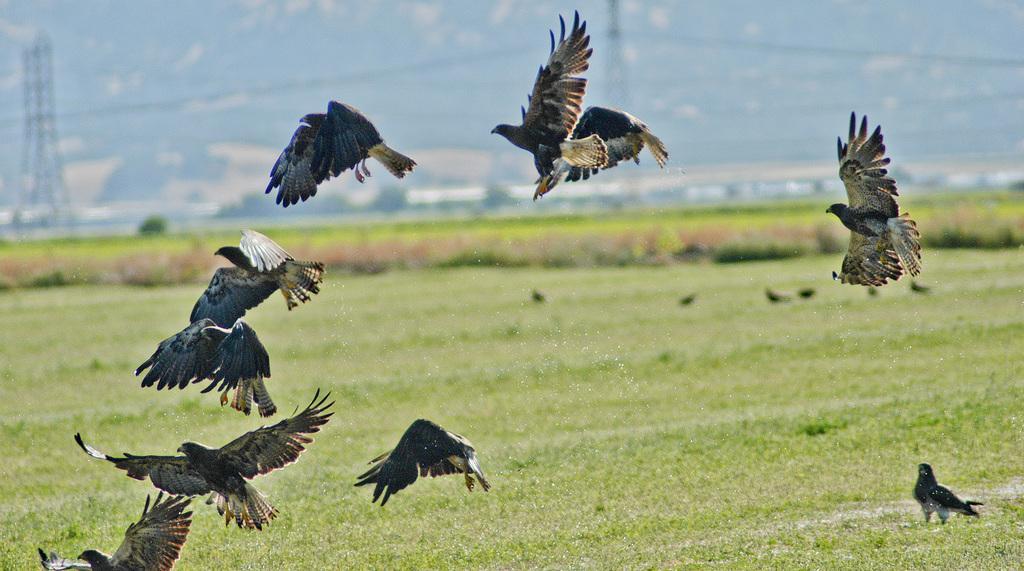In one or two sentences, can you explain what this image depicts? There are few birds flying in air and the ground is greenery and there are poles in the background. 